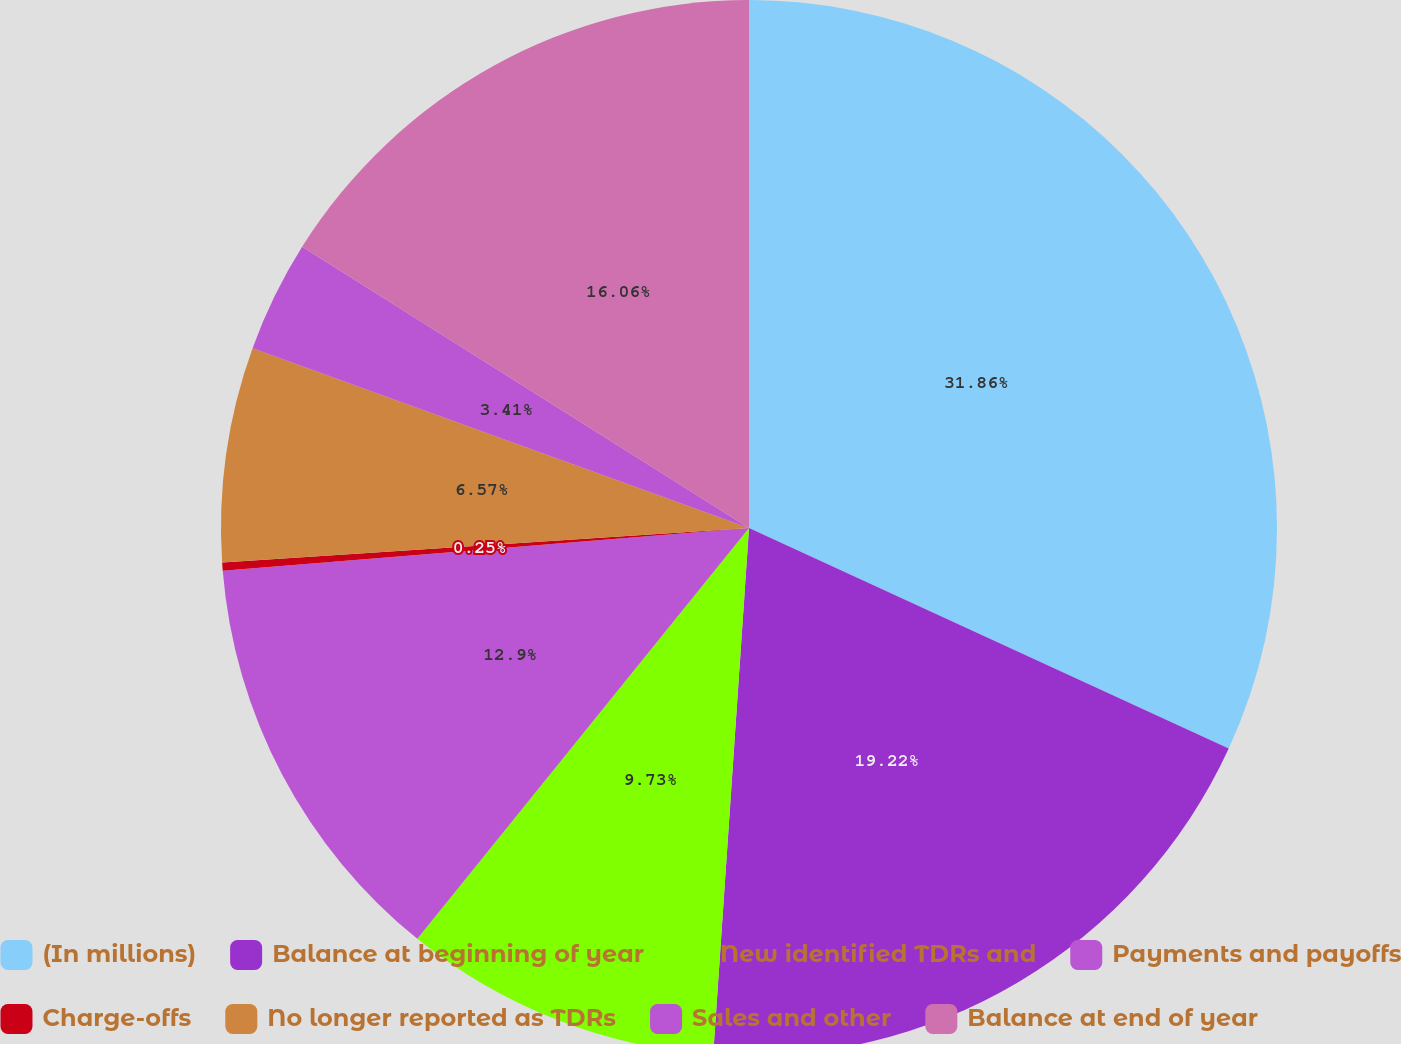Convert chart to OTSL. <chart><loc_0><loc_0><loc_500><loc_500><pie_chart><fcel>(In millions)<fcel>Balance at beginning of year<fcel>New identified TDRs and<fcel>Payments and payoffs<fcel>Charge-offs<fcel>No longer reported as TDRs<fcel>Sales and other<fcel>Balance at end of year<nl><fcel>31.86%<fcel>19.22%<fcel>9.73%<fcel>12.9%<fcel>0.25%<fcel>6.57%<fcel>3.41%<fcel>16.06%<nl></chart> 